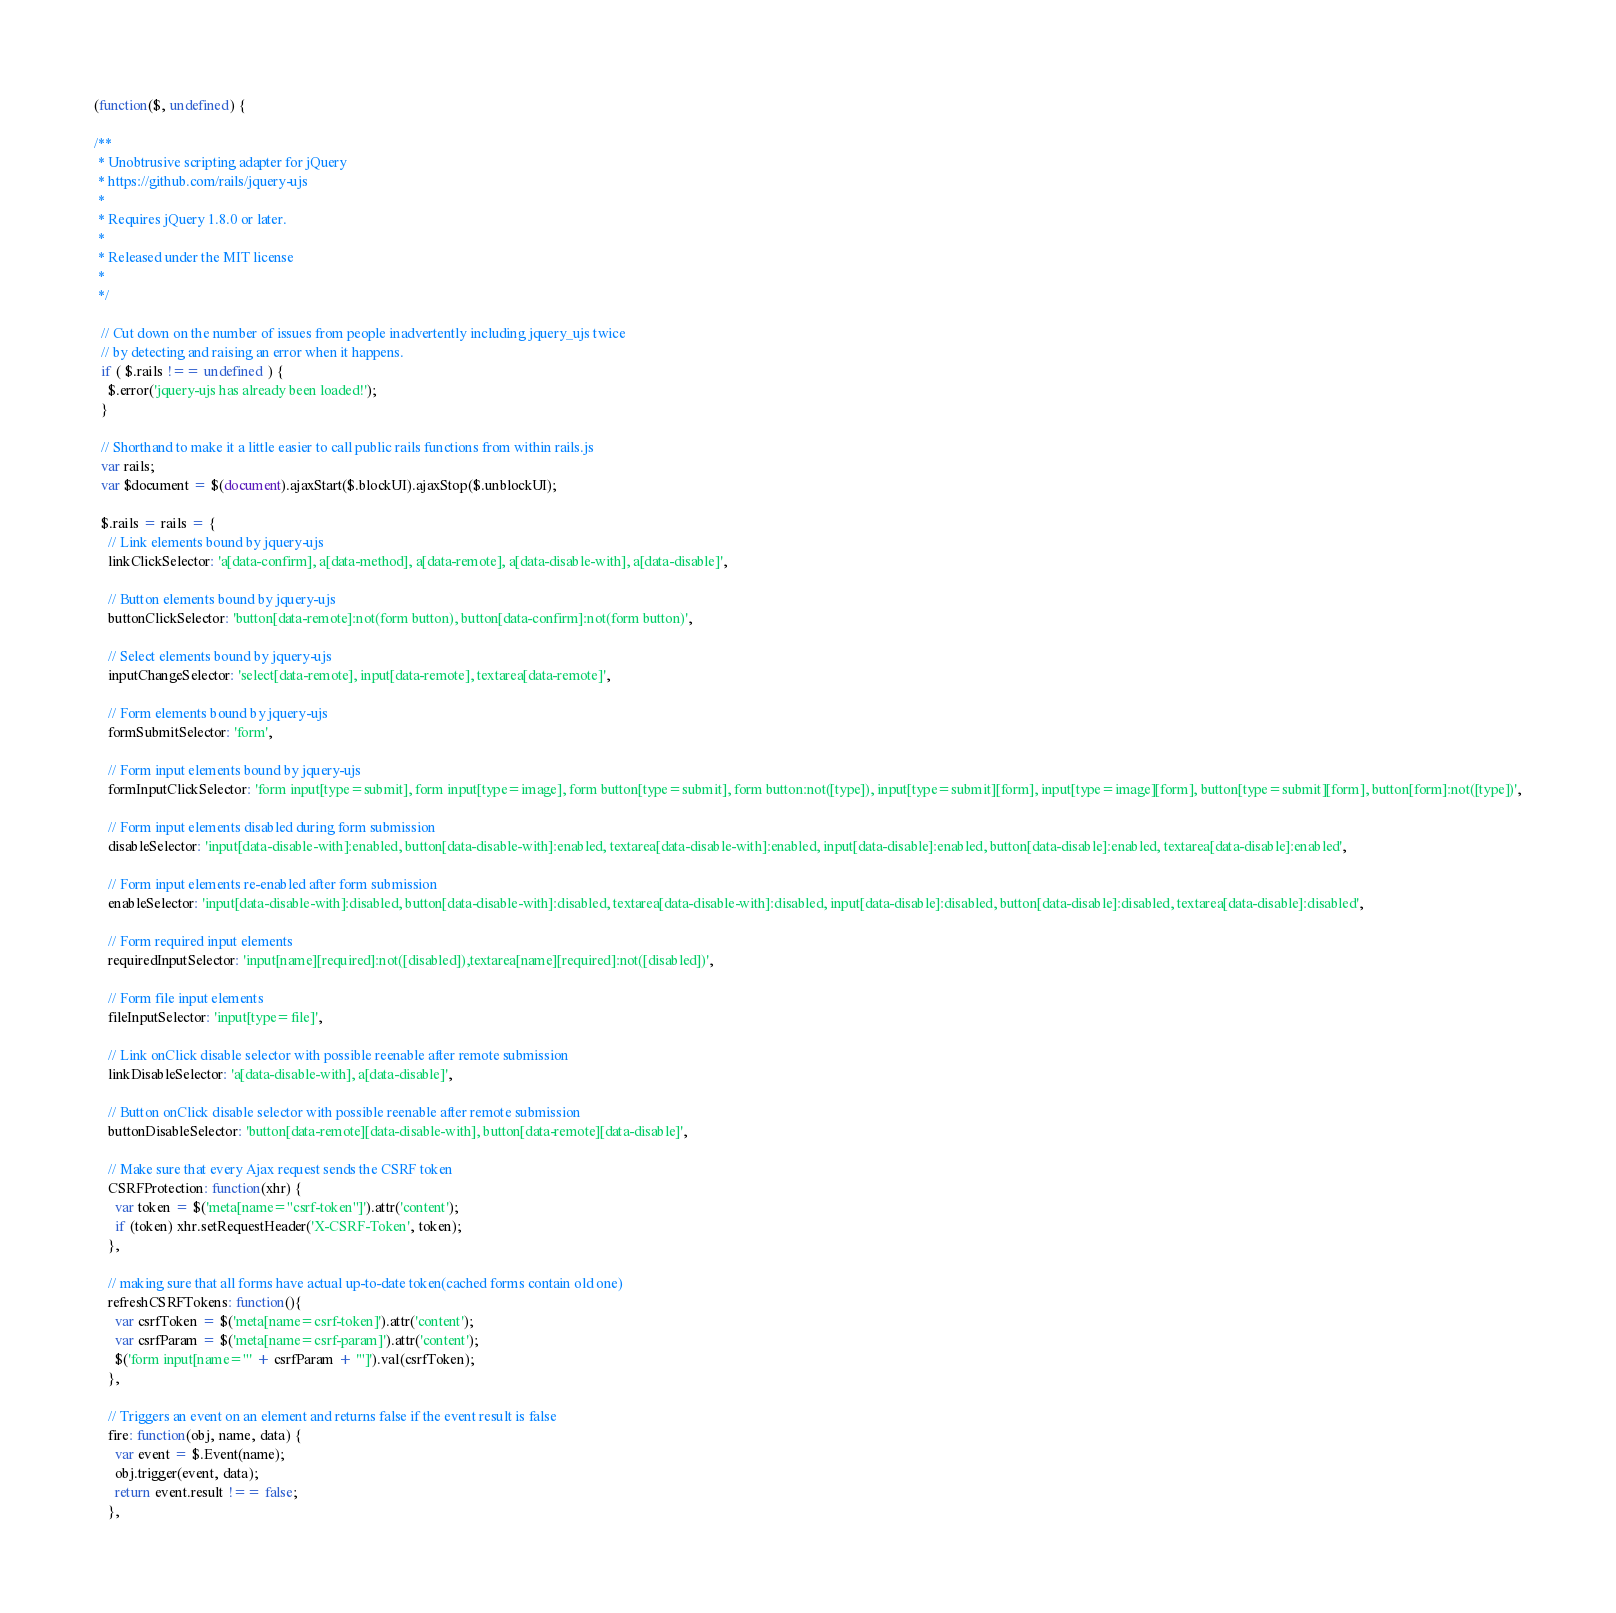Convert code to text. <code><loc_0><loc_0><loc_500><loc_500><_JavaScript_>(function($, undefined) {

/**
 * Unobtrusive scripting adapter for jQuery
 * https://github.com/rails/jquery-ujs
 *
 * Requires jQuery 1.8.0 or later.
 *
 * Released under the MIT license
 *
 */

  // Cut down on the number of issues from people inadvertently including jquery_ujs twice
  // by detecting and raising an error when it happens.
  if ( $.rails !== undefined ) {
    $.error('jquery-ujs has already been loaded!');
  }

  // Shorthand to make it a little easier to call public rails functions from within rails.js
  var rails;
  var $document = $(document).ajaxStart($.blockUI).ajaxStop($.unblockUI);

  $.rails = rails = {
    // Link elements bound by jquery-ujs
    linkClickSelector: 'a[data-confirm], a[data-method], a[data-remote], a[data-disable-with], a[data-disable]',

    // Button elements bound by jquery-ujs
    buttonClickSelector: 'button[data-remote]:not(form button), button[data-confirm]:not(form button)',

    // Select elements bound by jquery-ujs
    inputChangeSelector: 'select[data-remote], input[data-remote], textarea[data-remote]',

    // Form elements bound by jquery-ujs
    formSubmitSelector: 'form',

    // Form input elements bound by jquery-ujs
    formInputClickSelector: 'form input[type=submit], form input[type=image], form button[type=submit], form button:not([type]), input[type=submit][form], input[type=image][form], button[type=submit][form], button[form]:not([type])',

    // Form input elements disabled during form submission
    disableSelector: 'input[data-disable-with]:enabled, button[data-disable-with]:enabled, textarea[data-disable-with]:enabled, input[data-disable]:enabled, button[data-disable]:enabled, textarea[data-disable]:enabled',

    // Form input elements re-enabled after form submission
    enableSelector: 'input[data-disable-with]:disabled, button[data-disable-with]:disabled, textarea[data-disable-with]:disabled, input[data-disable]:disabled, button[data-disable]:disabled, textarea[data-disable]:disabled',

    // Form required input elements
    requiredInputSelector: 'input[name][required]:not([disabled]),textarea[name][required]:not([disabled])',

    // Form file input elements
    fileInputSelector: 'input[type=file]',

    // Link onClick disable selector with possible reenable after remote submission
    linkDisableSelector: 'a[data-disable-with], a[data-disable]',

    // Button onClick disable selector with possible reenable after remote submission
    buttonDisableSelector: 'button[data-remote][data-disable-with], button[data-remote][data-disable]',

    // Make sure that every Ajax request sends the CSRF token
    CSRFProtection: function(xhr) {
      var token = $('meta[name="csrf-token"]').attr('content');
      if (token) xhr.setRequestHeader('X-CSRF-Token', token);
    },

    // making sure that all forms have actual up-to-date token(cached forms contain old one)
    refreshCSRFTokens: function(){
      var csrfToken = $('meta[name=csrf-token]').attr('content');
      var csrfParam = $('meta[name=csrf-param]').attr('content');
      $('form input[name="' + csrfParam + '"]').val(csrfToken);
    },

    // Triggers an event on an element and returns false if the event result is false
    fire: function(obj, name, data) {
      var event = $.Event(name);
      obj.trigger(event, data);
      return event.result !== false;
    },
</code> 